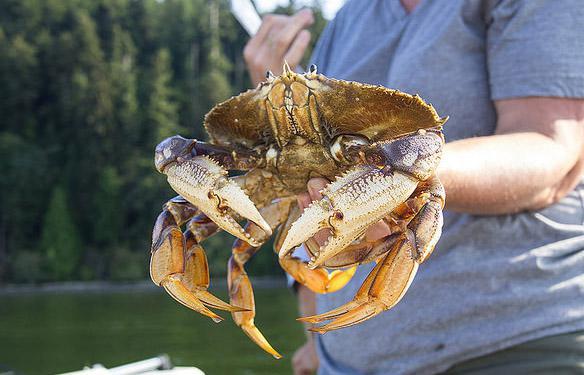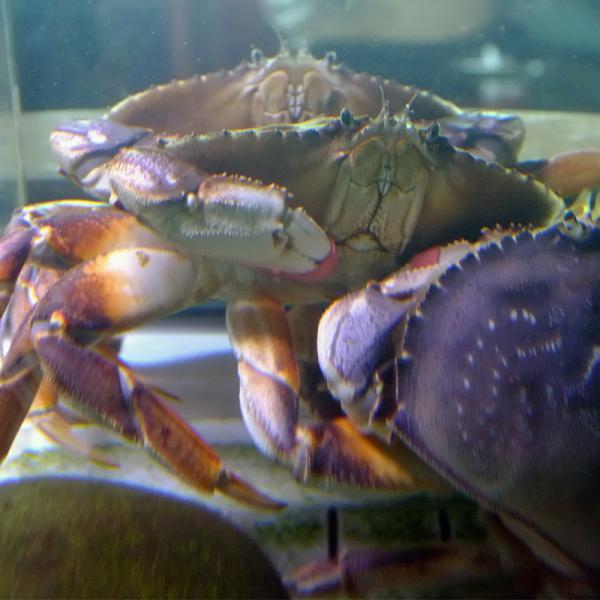The first image is the image on the left, the second image is the image on the right. Examine the images to the left and right. Is the description "Each image includes a forward-facing crab, and in one image, a crab is held by a bare hand." accurate? Answer yes or no. Yes. The first image is the image on the left, the second image is the image on the right. Examine the images to the left and right. Is the description "In at least one image there is an ungloved hand holding a live crab." accurate? Answer yes or no. Yes. 